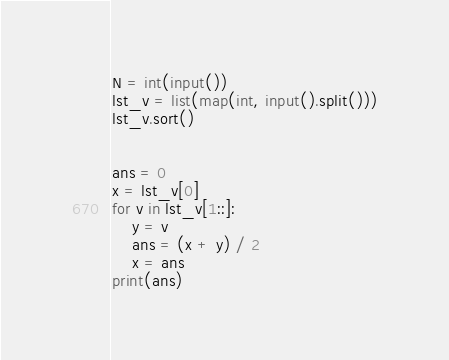<code> <loc_0><loc_0><loc_500><loc_500><_Python_>N = int(input())
lst_v = list(map(int, input().split()))
lst_v.sort()


ans = 0
x = lst_v[0]
for v in lst_v[1::]:
    y = v
    ans = (x + y) / 2
    x = ans
print(ans)
</code> 